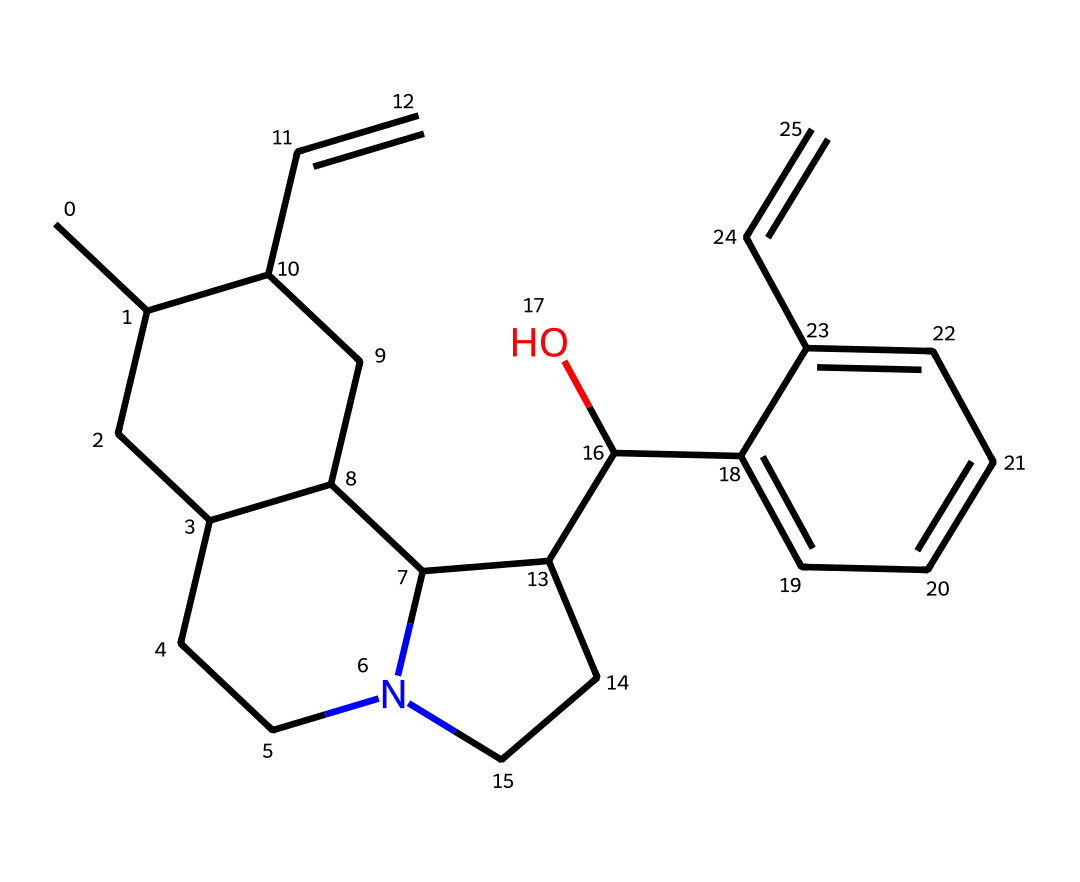What is the molecular formula of quinine? To determine the molecular formula, we count the number of each type of atom represented in the SMILES structure. In the given SMILES, there are Carbon (C), Hydrogen (H), Oxygen (O), and Nitrogen (N) atoms. The tally shows C=20, H=24, O=1, and N=1, which gives us a molecular formula of C20H24N2O2.
Answer: C20H24N2O2 How many rings are present in the structural formula? By examining the SMILES representation, we identify cyclic structures indicated by the numbers in the SMILES. There are five numbers that indicate connections between carbons, revealing that there are four distinct rings in the structure.
Answer: four Which atom in quinine is responsible for its pharmacological effects? The nitrogen atom in the structure is crucial, as alkaloids, including quinine, often possess pharmacological properties due to the presence of one or more nitrogen atoms. This is why the presence of nitrogen is a defining characteristic in evaluating its effects.
Answer: nitrogen What functional group is indicated in quinine? Analyzing the structure, we observe the presence of a hydroxyl group (-OH), which is a characteristic functional group in quinine. The ‘C(O)’ notation indicates a carbon atom bonded to an oxygen atom and a hydrogen atom, showing it's a hydroxyl group.
Answer: hydroxyl group Does quinine contain any stereocenters? In the SMILES representation, stereocenters can be inferred from certain arrangements of carbon atoms bonded to four different groups. Upon careful examination of the structure, we find that there are at least three carbon atoms that are bonded to four different substituents, indicating that stereocenters are indeed present in quinine.
Answer: yes 